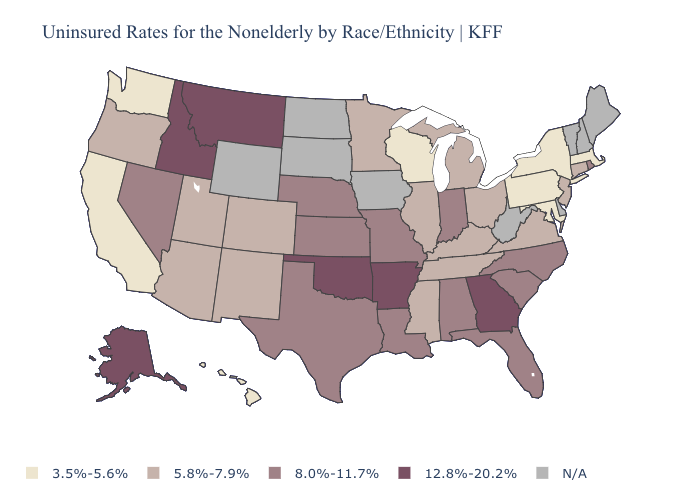What is the highest value in the South ?
Give a very brief answer. 12.8%-20.2%. What is the highest value in the West ?
Quick response, please. 12.8%-20.2%. Name the states that have a value in the range 8.0%-11.7%?
Concise answer only. Alabama, Florida, Indiana, Kansas, Louisiana, Missouri, Nebraska, Nevada, North Carolina, Rhode Island, South Carolina, Texas. Among the states that border Vermont , which have the highest value?
Answer briefly. Massachusetts, New York. What is the value of Ohio?
Be succinct. 5.8%-7.9%. What is the lowest value in the South?
Short answer required. 3.5%-5.6%. What is the value of New Mexico?
Answer briefly. 5.8%-7.9%. Does Georgia have the highest value in the USA?
Write a very short answer. Yes. What is the value of New Hampshire?
Keep it brief. N/A. Which states have the highest value in the USA?
Short answer required. Alaska, Arkansas, Georgia, Idaho, Montana, Oklahoma. Does the first symbol in the legend represent the smallest category?
Quick response, please. Yes. Name the states that have a value in the range N/A?
Give a very brief answer. Delaware, Iowa, Maine, New Hampshire, North Dakota, South Dakota, Vermont, West Virginia, Wyoming. Which states have the highest value in the USA?
Concise answer only. Alaska, Arkansas, Georgia, Idaho, Montana, Oklahoma. Among the states that border Missouri , does Oklahoma have the highest value?
Quick response, please. Yes. What is the value of Texas?
Answer briefly. 8.0%-11.7%. 